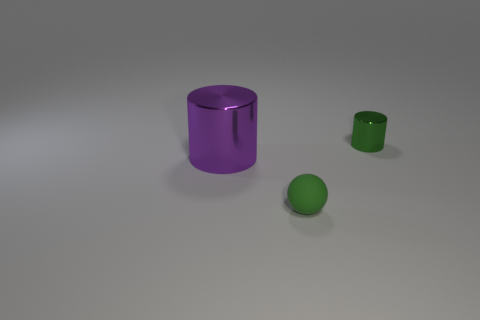What materials do these objects appear to be made of? The objects in the image give the impression of being made out of a smooth, matte material, possibly plastic or a digitally rendered equivalent, showcasing no reflections that would suggest a metallic or glossy finish. 